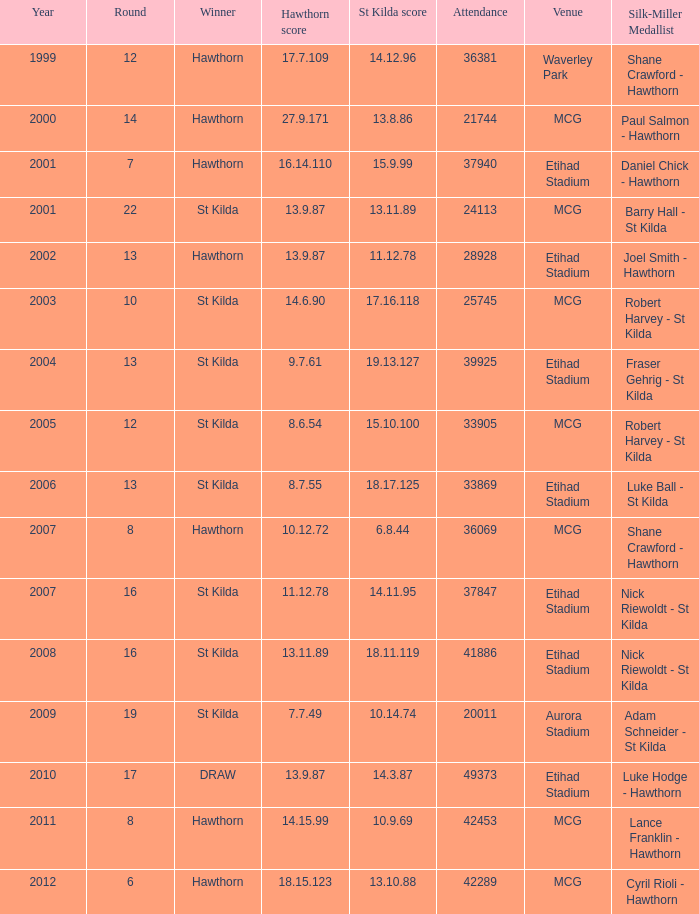What items are listed in the round with a hawthorn score of 17.7.109? 12.0. 